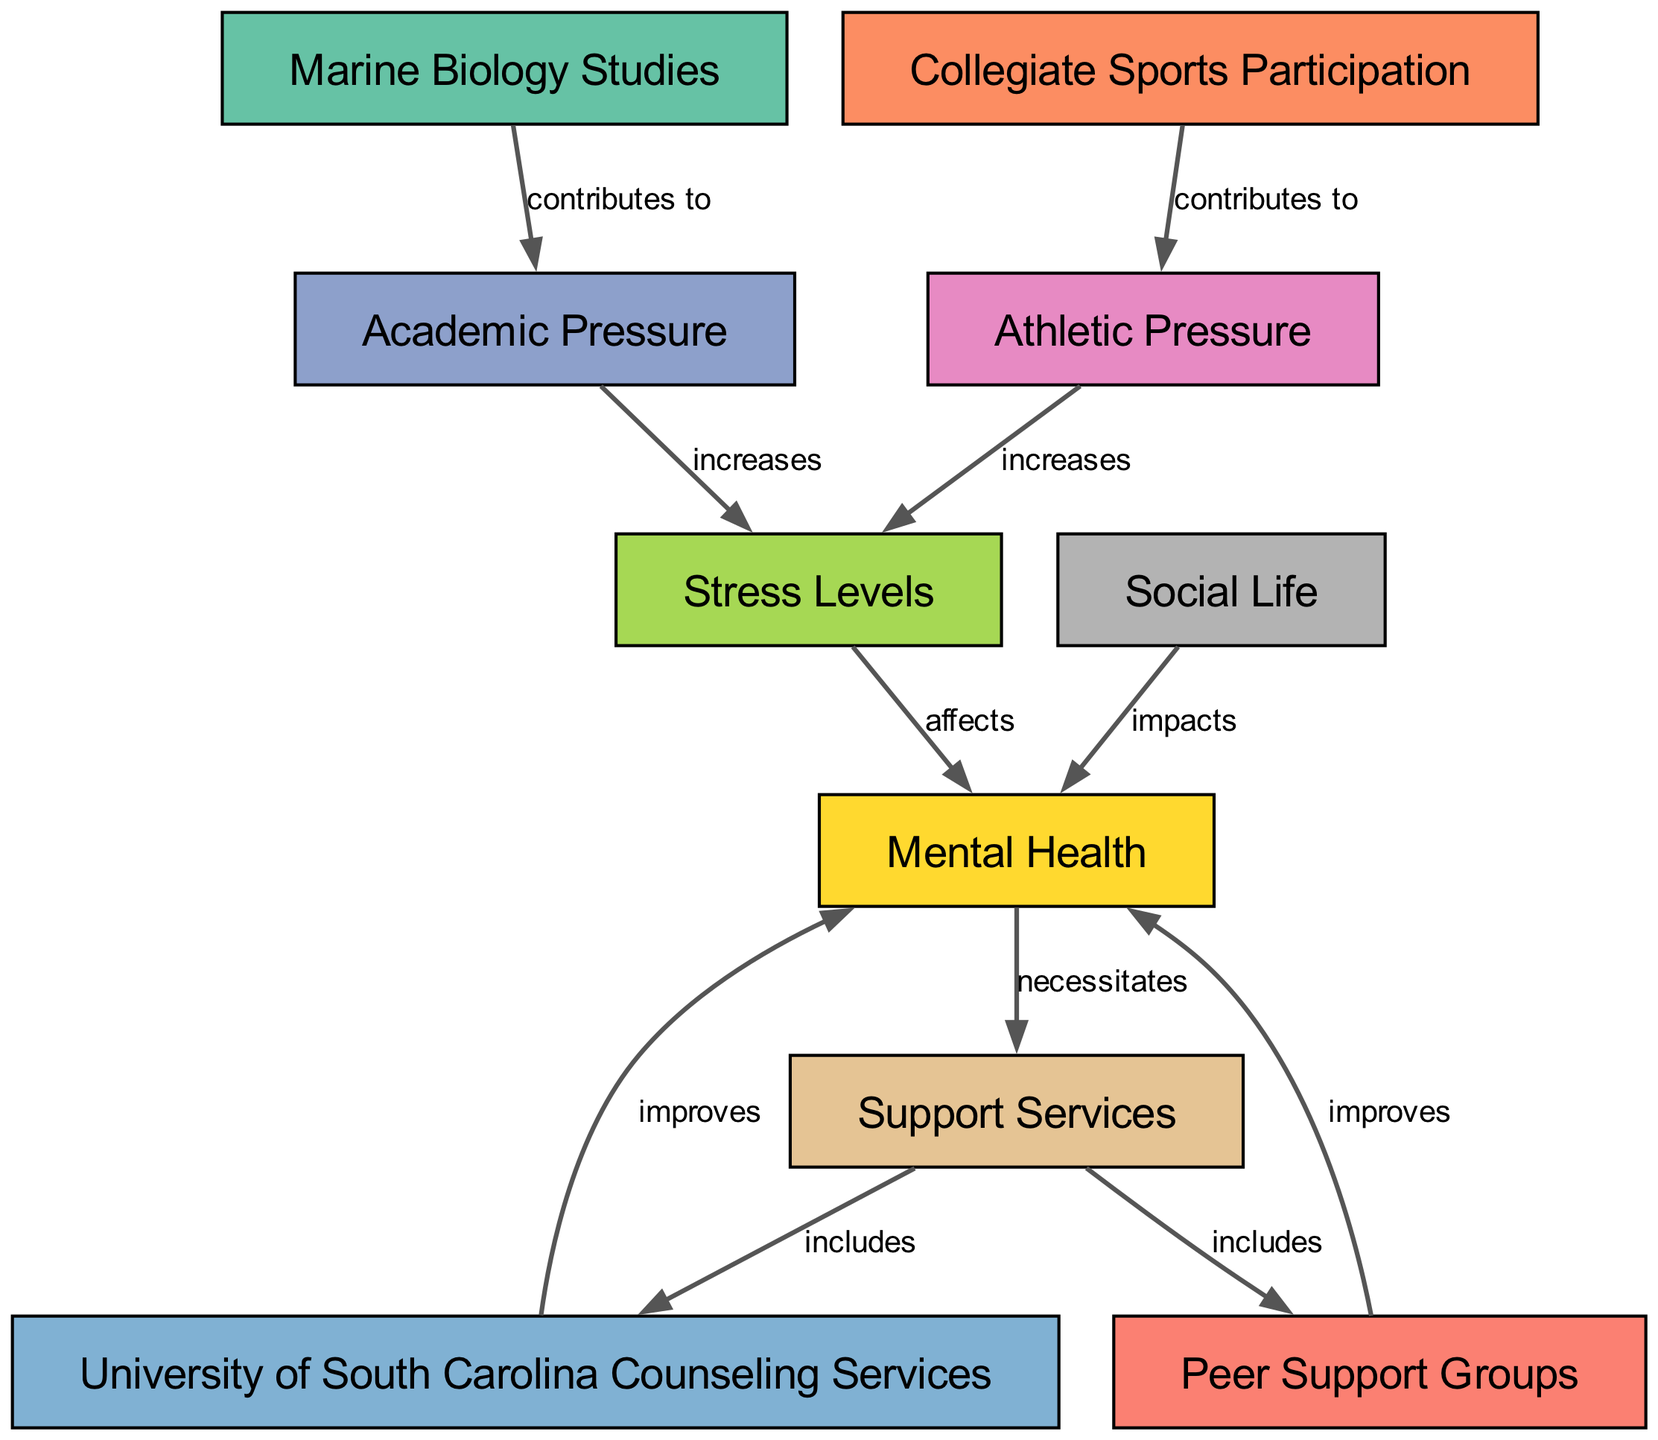What is the total number of nodes in the diagram? The nodes listed in the diagram are: Marine Biology Studies, Collegiate Sports Participation, Academic Pressure, Athletic Pressure, Stress Levels, Mental Health, Support Services, Social Life, University of South Carolina Counseling Services, and Peer Support Groups. There are a total of 10 unique nodes.
Answer: 10 What relationship contributes to increased stress levels from marine biology studies? The diagram indicates that "Marine Biology Studies" contributes to "Academic Pressure," which in turn increases "Stress Levels." Thus, the contribution is from Marine Biology Studies to Academic Pressure for increasing stress.
Answer: Academic Pressure What are the two types of pressures contributing to stress levels? Reviewing the diagram, "Academic Pressure" from Marine Biology Studies and "Athletic Pressure" from Collegiate Sports Participation both lead to increased Stress Levels. Both pressures must be acknowledged as significant sources.
Answer: Academic Pressure and Athletic Pressure Which support service is specifically included to improve mental health? The diagram shows that "University of South Carolina Counseling Services" is indicated as an improvement factor for "Mental Health," along with "Peer Support Groups." This specificity identifies the correct service impacting mental health positively.
Answer: University of South Carolina Counseling Services How does social life impact mental health? According to the diagram, "Social Life" impacts "Mental Health," indicating a negative or positive correlation depending on context. The relationship illustrates an important consideration for students balancing academics and athletics.
Answer: Impacts Which two support services are included in the support services category? Within the diagram, both "University of South Carolina Counseling Services" and "Peer Support Groups" are noted as parts of "Support Services." These illustrate the available resources for mental health support.
Answer: University of South Carolina Counseling Services and Peer Support Groups What is affected by increased stress levels? The diagram directly states that increased "Stress Levels" affects "Mental Health." This shows the causal connection in terms of mental well-being related to student pressures.
Answer: Mental Health What does the node "Support Services" necessitate? The node "Mental Health" necessitates "Support Services" according to the flow of the diagram. This identifies the vital role that support services play in addressing mental health needs.
Answer: Support Services What are the contributions to stress levels from the two types of participation? "Academic Pressure" from Marine Biology Studies and "Athletic Pressure" from Collegiate Sports Participation are identified as contributions to Stress Levels. Both forms of student involvement create additional pressure leading to stress.
Answer: Academic Pressure and Athletic Pressure 